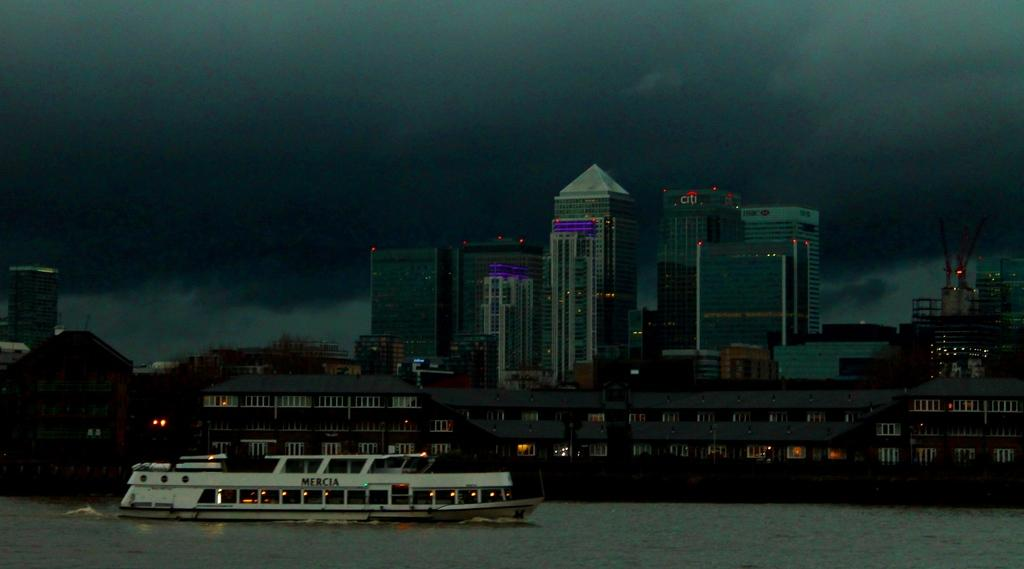<image>
Describe the image concisely. a gloomy night picture of a ferry in front of buildings such as CiTi 